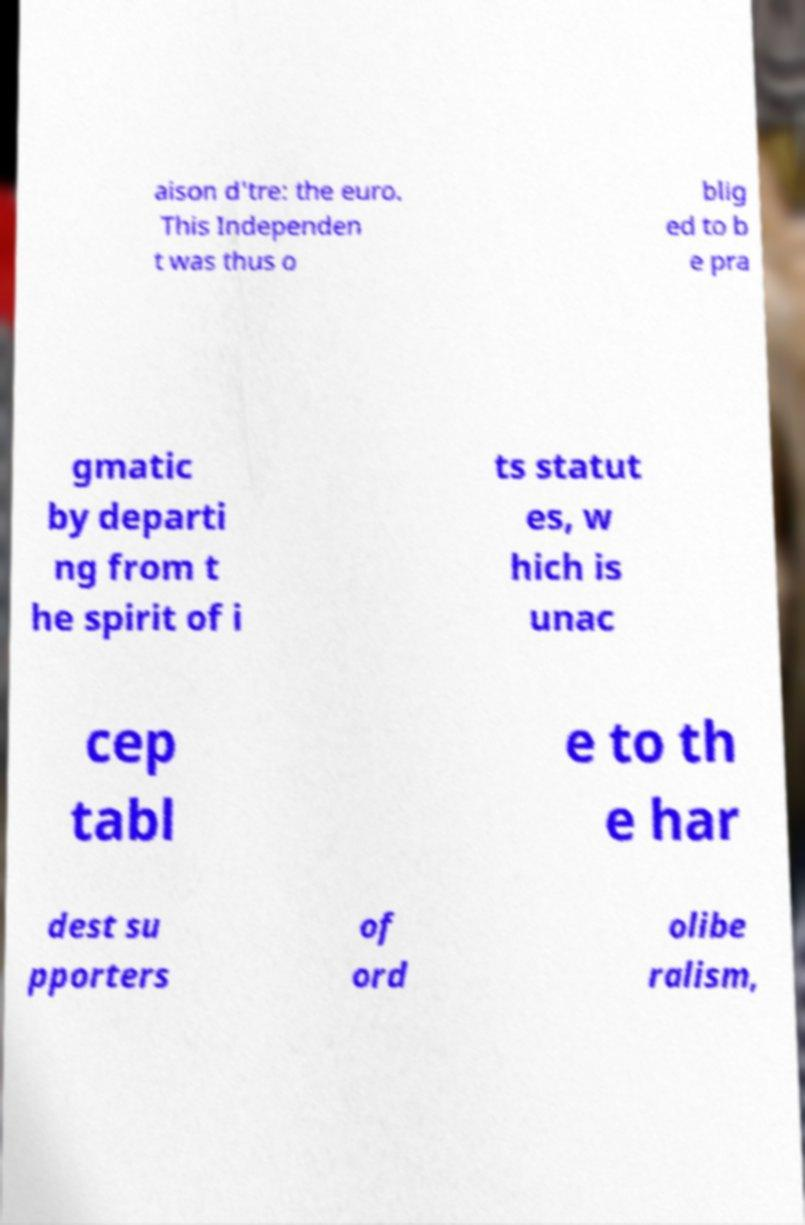There's text embedded in this image that I need extracted. Can you transcribe it verbatim? aison d'tre: the euro. This Independen t was thus o blig ed to b e pra gmatic by departi ng from t he spirit of i ts statut es, w hich is unac cep tabl e to th e har dest su pporters of ord olibe ralism, 